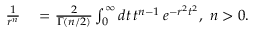<formula> <loc_0><loc_0><loc_500><loc_500>\begin{array} { r l } { \frac { 1 } { r ^ { n } } } & = \frac { 2 } { \Gamma ( n / 2 ) } \int _ { 0 } ^ { \infty } d t \, t ^ { n - 1 } \, e ^ { - r ^ { 2 } t ^ { 2 } } , n > 0 . } \end{array}</formula> 